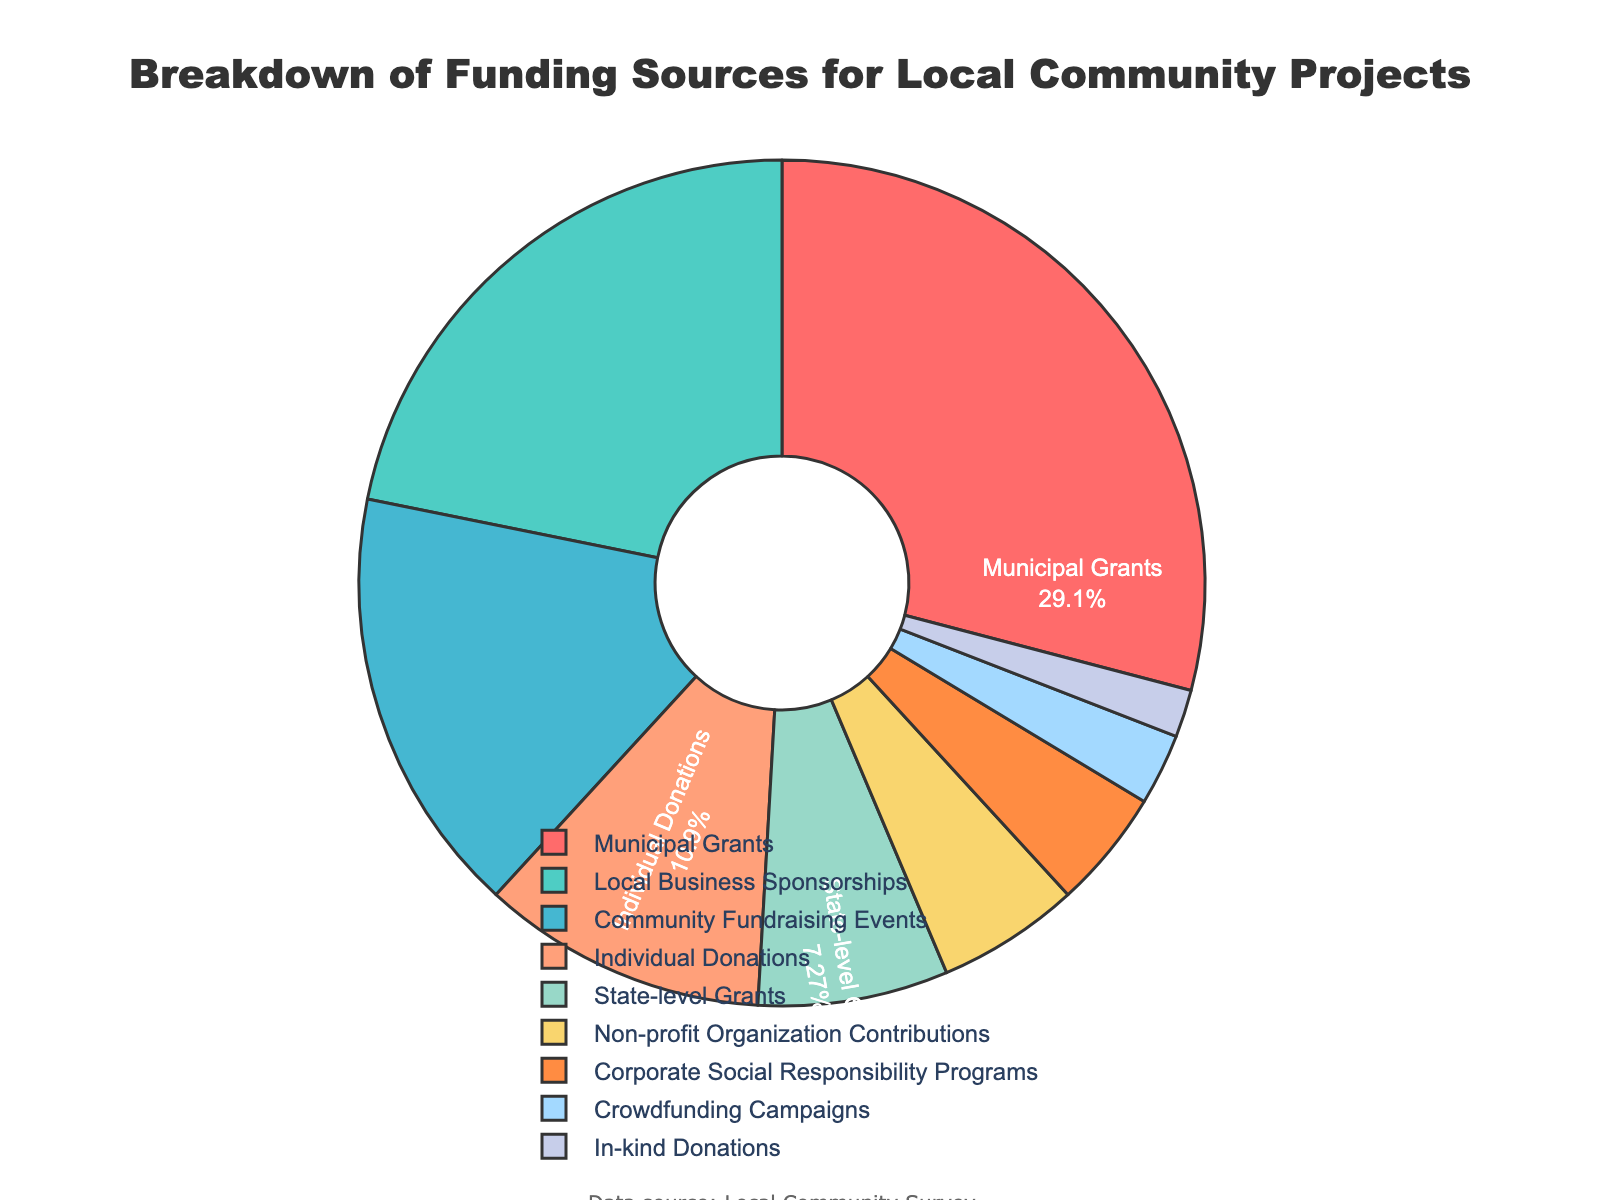What is the largest funding source? Based on the size of the pie chart segments, the largest funding source is "Municipal Grants" which occupies the biggest portion.
Answer: Municipal Grants How much more percentage does Local Business Sponsorships contribute compared to Individual Donations? Local Business Sponsorships contribute 24%, and Individual Donations contribute 12%. The difference is 24% - 12% = 12%.
Answer: 12% Which funding sources contribute less than 10% each? By inspecting the segments that are smaller than others and checking their labels, the funding sources contributing less than 10% each are State-level Grants (8%), Non-profit Organization Contributions (6%), Corporate Social Responsibility Programs (5%), Crowdfunding Campaigns (3%), and In-kind Donations (2%).
Answer: State-level Grants, Non-profit Organization Contributions, Corporate Social Responsibility Programs, Crowdfunding Campaigns, In-kind Donations What is the combined percentage of community-related funding sources (Community Fundraising Events and Individual Donations)? Community Fundraising Events contribute 18%, and Individual Donations contribute 12%. The combined percentage is 18% + 12% = 30%.
Answer: 30% How does the percentage of Corporate Social Responsibility Programs compare to Crowdfunding Campaigns? Corporate Social Responsibility Programs contribute 5%, while Crowdfunding Campaigns contribute 3%. Therefore, Corporate Social Responsibility Programs contribute 2% more.
Answer: Corporate Social Responsibility Programs contribute 2% more Which segment is represented by a red color in the pie chart? The red color is used for the Municipal Grants segment, as seen in the pie chart.
Answer: Municipal Grants Between Local Business Sponsorships and Community Fundraising Events, which has a higher contribution, and by how much? Local Business Sponsorships contribute 24%, while Community Fundraising Events contribute 18%. The difference is 24% - 18% = 6%, so Local Business Sponsorships have a higher contribution by 6%.
Answer: Local Business Sponsorships by 6% What percentage of funding comes from grants (Municipal Grants and State-level Grants combined)? Municipal Grants contribute 32%, and State-level Grants contribute 8%. The combined percentage from grants is 32% + 8% = 40%.
Answer: 40% Which funding source contributes the least to local community projects? The smallest segment on the pie chart, representing the lowest contribution, is In-kind Donations with 2%.
Answer: In-kind Donations 